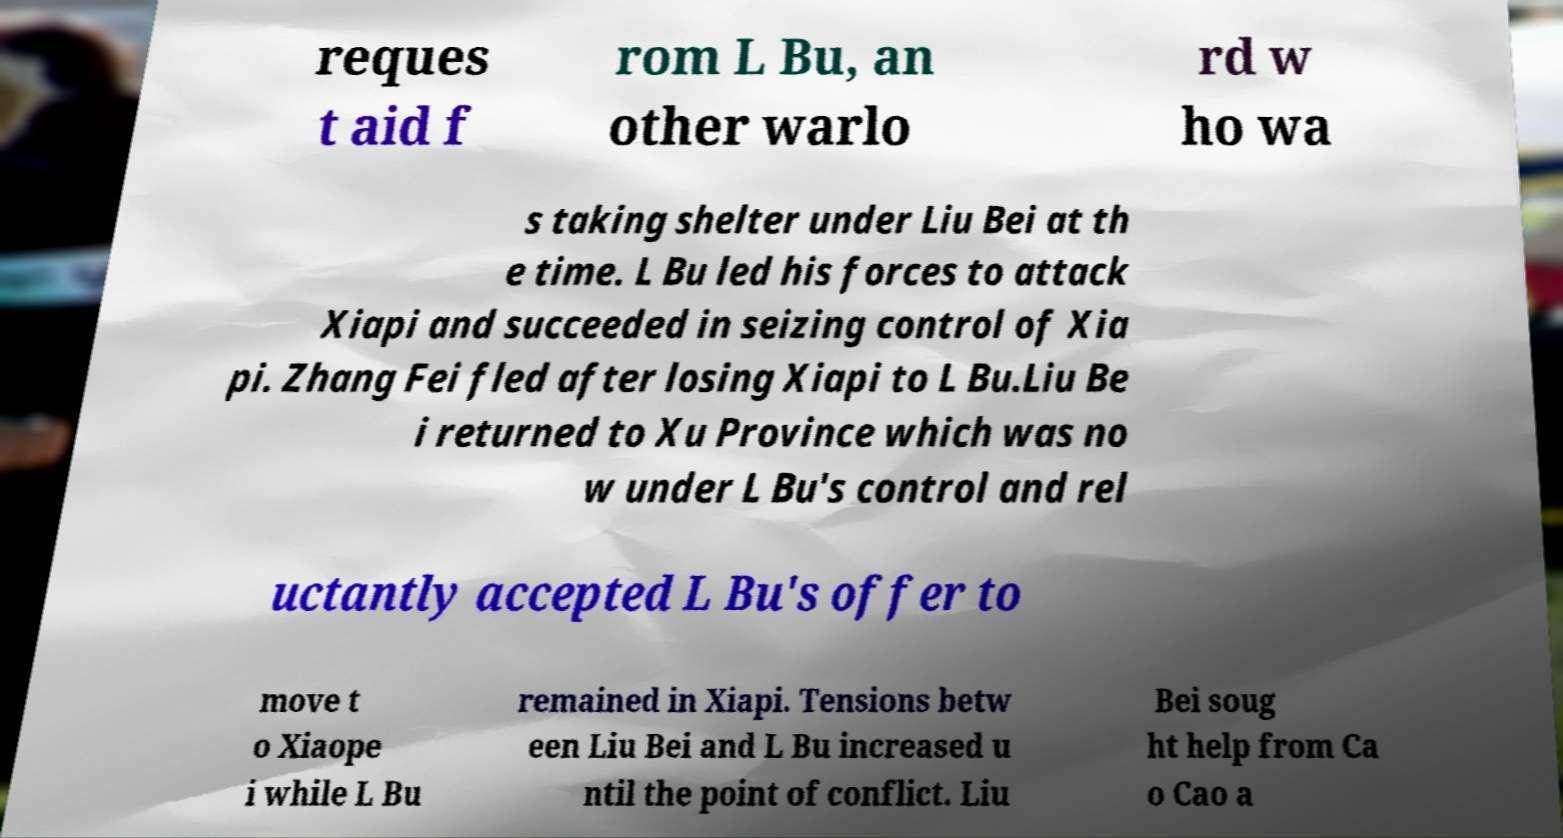There's text embedded in this image that I need extracted. Can you transcribe it verbatim? reques t aid f rom L Bu, an other warlo rd w ho wa s taking shelter under Liu Bei at th e time. L Bu led his forces to attack Xiapi and succeeded in seizing control of Xia pi. Zhang Fei fled after losing Xiapi to L Bu.Liu Be i returned to Xu Province which was no w under L Bu's control and rel uctantly accepted L Bu's offer to move t o Xiaope i while L Bu remained in Xiapi. Tensions betw een Liu Bei and L Bu increased u ntil the point of conflict. Liu Bei soug ht help from Ca o Cao a 